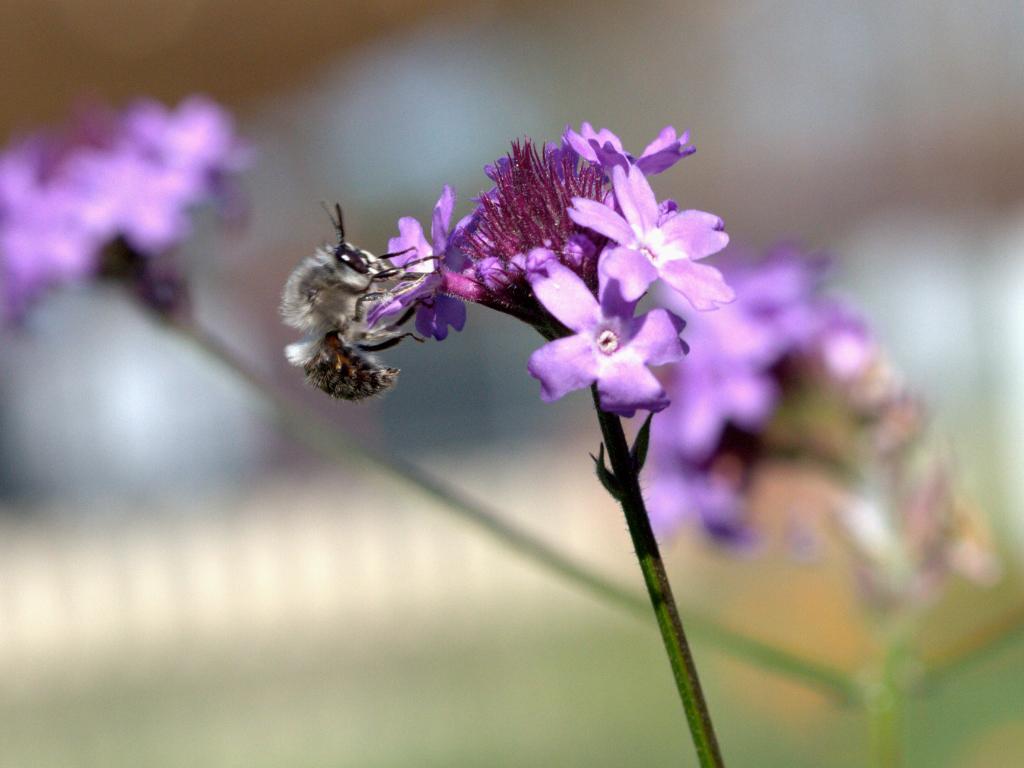In one or two sentences, can you explain what this image depicts? In this image, we can see flowers and stem. Here we can see an insect on the flower. Background we can see a blur view. 